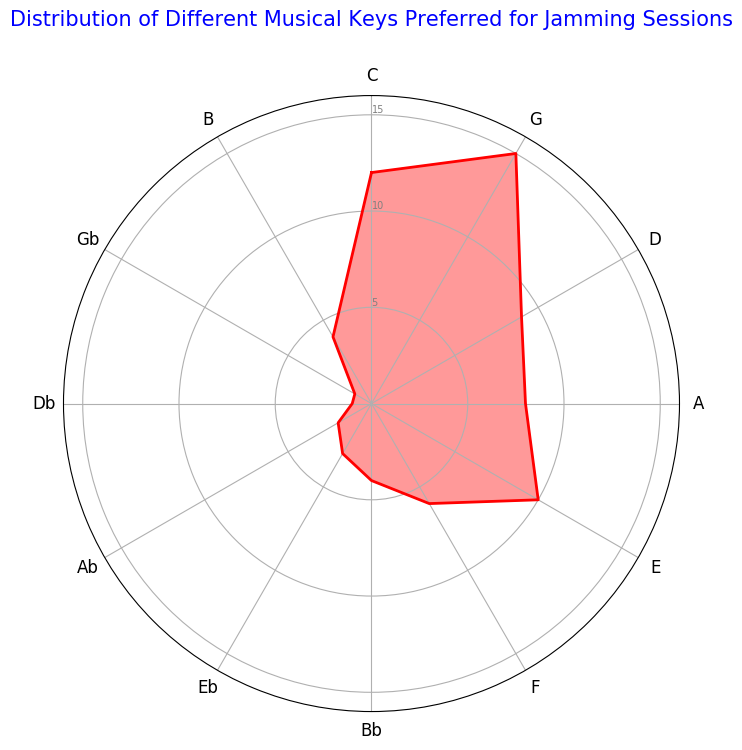Which key has the highest frequency for jamming sessions? The highest frequency bar on the radar chart is at the position corresponding to the key G.
Answer: G Which two keys have the lowest frequency? The lowest points on the radar chart are at the positions corresponding to the keys Db and Gb, both with the same lowest frequency.
Answer: Db and Gb How many keys have a frequency of 8 or above? By examining the radar chart, we see the bars for keys C, G, D, A, and E have frequencies of 12, 15, 9, 8, and 10, respectively, all of which are 8 or above.
Answer: 5 What is the overall range of the frequencies depicted in the chart? The range is calculated by subtracting the minimum value (1 for Db and Gb) from the maximum value (15 for G).
Answer: 14 By how much does the frequency of the key with the highest value exceed the frequency of the key A? The key with the highest value, G, has a frequency of 15. The frequency of key A is 8. The difference between them is 15 - 8.
Answer: 7 Compare the frequencies of the keys Bb and B. Which one is higher and by how much? The frequency of Bb is 4 and the frequency of B is also 4. Therefore, there is no difference in their frequencies.
Answer: Both are equal What is the average frequency of the keys D, A, and E combined? The frequencies of the keys are D: 9, A: 8, and E: 10. Their average is calculated by (9 + 8 + 10) / 3.
Answer: 9 If you combine the frequencies of the keys F, Bb, and Eb, what would be the total frequency? The frequencies are F: 6, Bb: 4, Eb: 3. Adding them gives 6 + 4 + 3.
Answer: 13 How many keys have a frequency strictly less than 5? The radar chart shows the frequencies for Bb: 4, Eb: 3, Ab: 2, Db: 1, and Gb: 1, which are all less than 5.
Answer: 5 